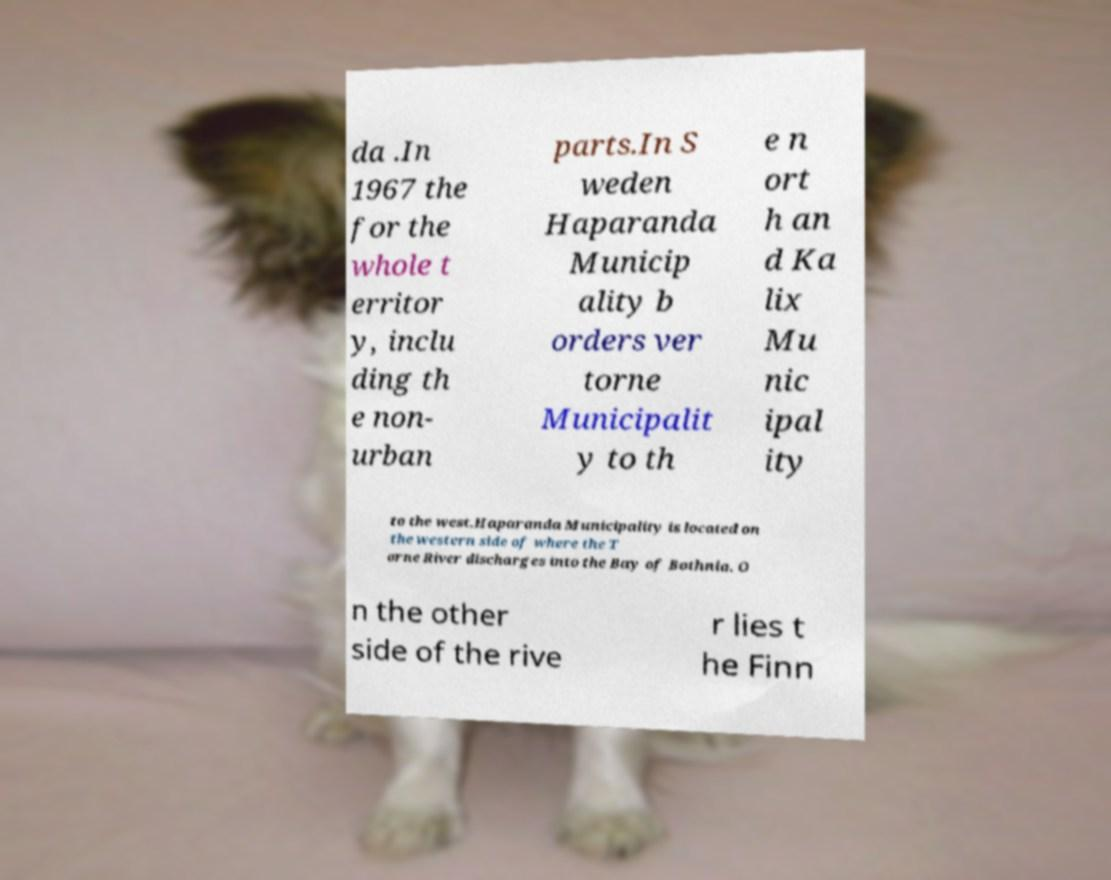Can you accurately transcribe the text from the provided image for me? da .In 1967 the for the whole t erritor y, inclu ding th e non- urban parts.In S weden Haparanda Municip ality b orders ver torne Municipalit y to th e n ort h an d Ka lix Mu nic ipal ity to the west.Haparanda Municipality is located on the western side of where the T orne River discharges into the Bay of Bothnia. O n the other side of the rive r lies t he Finn 